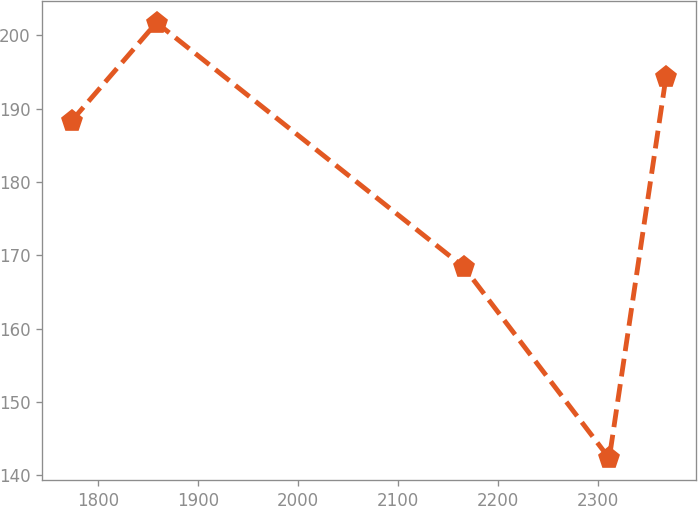<chart> <loc_0><loc_0><loc_500><loc_500><line_chart><ecel><fcel>Unnamed: 1<nl><fcel>1773.75<fcel>188.34<nl><fcel>1858.5<fcel>201.71<nl><fcel>2165.57<fcel>168.39<nl><fcel>2310.98<fcel>142.33<nl><fcel>2367.66<fcel>194.28<nl></chart> 